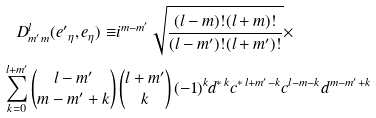<formula> <loc_0><loc_0><loc_500><loc_500>D ^ { l } _ { m ^ { \prime } m } ( { e ^ { \prime } } _ { \eta } , { e } _ { \eta } ) \equiv & i ^ { m - m ^ { \prime } } \sqrt { \frac { ( l - m ) ! ( l + m ) ! } { ( l - m ^ { \prime } ) ! ( l + m ^ { \prime } ) ! } } \times \\ \sum _ { k = 0 } ^ { l + m ^ { \prime } } \begin{pmatrix} l - m ^ { \prime } \\ m - m ^ { \prime } + k \end{pmatrix} & \begin{pmatrix} l + m ^ { \prime } \\ k \end{pmatrix} ( - 1 ) ^ { k } d ^ { * \, k } c ^ { * \, l + m ^ { \prime } - k } c ^ { l - m - k } d ^ { m - m ^ { \prime } + k }</formula> 